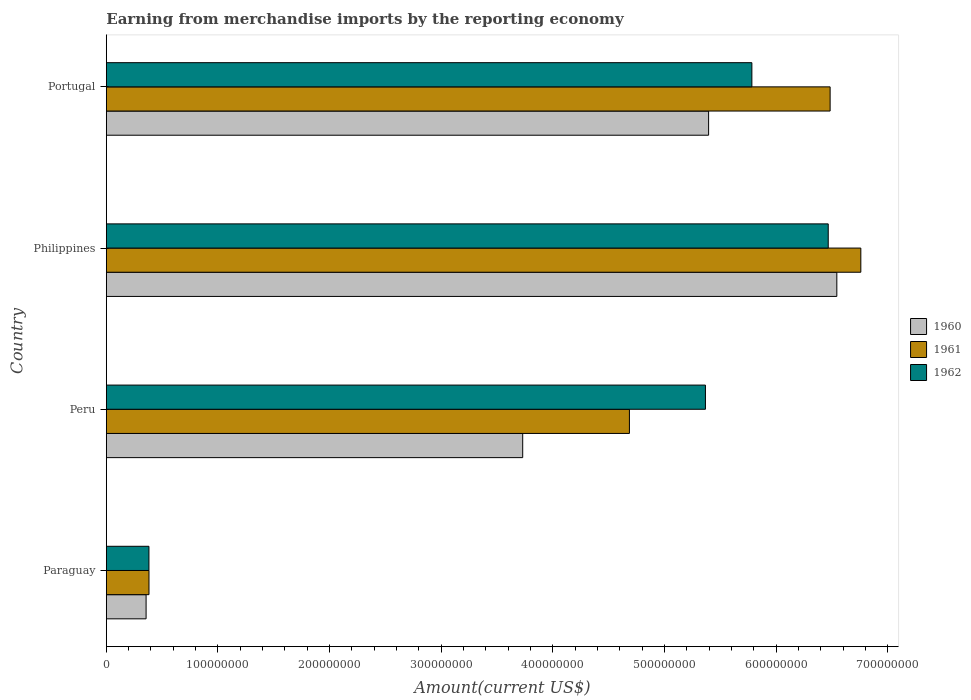How many different coloured bars are there?
Ensure brevity in your answer.  3. Are the number of bars on each tick of the Y-axis equal?
Offer a very short reply. Yes. How many bars are there on the 4th tick from the top?
Keep it short and to the point. 3. In how many cases, is the number of bars for a given country not equal to the number of legend labels?
Provide a short and direct response. 0. What is the amount earned from merchandise imports in 1962 in Peru?
Ensure brevity in your answer.  5.37e+08. Across all countries, what is the maximum amount earned from merchandise imports in 1962?
Provide a short and direct response. 6.47e+08. Across all countries, what is the minimum amount earned from merchandise imports in 1961?
Provide a succinct answer. 3.82e+07. In which country was the amount earned from merchandise imports in 1962 minimum?
Offer a terse response. Paraguay. What is the total amount earned from merchandise imports in 1961 in the graph?
Provide a succinct answer. 1.83e+09. What is the difference between the amount earned from merchandise imports in 1961 in Peru and that in Portugal?
Make the answer very short. -1.80e+08. What is the difference between the amount earned from merchandise imports in 1960 in Peru and the amount earned from merchandise imports in 1962 in Portugal?
Your response must be concise. -2.05e+08. What is the average amount earned from merchandise imports in 1961 per country?
Provide a succinct answer. 4.58e+08. What is the difference between the amount earned from merchandise imports in 1962 and amount earned from merchandise imports in 1960 in Peru?
Offer a very short reply. 1.64e+08. What is the ratio of the amount earned from merchandise imports in 1961 in Peru to that in Philippines?
Provide a succinct answer. 0.69. Is the difference between the amount earned from merchandise imports in 1962 in Peru and Portugal greater than the difference between the amount earned from merchandise imports in 1960 in Peru and Portugal?
Provide a short and direct response. Yes. What is the difference between the highest and the second highest amount earned from merchandise imports in 1961?
Give a very brief answer. 2.75e+07. What is the difference between the highest and the lowest amount earned from merchandise imports in 1961?
Keep it short and to the point. 6.38e+08. In how many countries, is the amount earned from merchandise imports in 1961 greater than the average amount earned from merchandise imports in 1961 taken over all countries?
Keep it short and to the point. 3. What does the 3rd bar from the top in Philippines represents?
Make the answer very short. 1960. Is it the case that in every country, the sum of the amount earned from merchandise imports in 1962 and amount earned from merchandise imports in 1961 is greater than the amount earned from merchandise imports in 1960?
Your answer should be compact. Yes. How many bars are there?
Provide a short and direct response. 12. Are all the bars in the graph horizontal?
Ensure brevity in your answer.  Yes. How many countries are there in the graph?
Keep it short and to the point. 4. What is the difference between two consecutive major ticks on the X-axis?
Give a very brief answer. 1.00e+08. Are the values on the major ticks of X-axis written in scientific E-notation?
Give a very brief answer. No. Does the graph contain grids?
Your answer should be very brief. No. What is the title of the graph?
Offer a terse response. Earning from merchandise imports by the reporting economy. What is the label or title of the X-axis?
Give a very brief answer. Amount(current US$). What is the label or title of the Y-axis?
Ensure brevity in your answer.  Country. What is the Amount(current US$) of 1960 in Paraguay?
Your response must be concise. 3.56e+07. What is the Amount(current US$) in 1961 in Paraguay?
Your response must be concise. 3.82e+07. What is the Amount(current US$) in 1962 in Paraguay?
Offer a very short reply. 3.82e+07. What is the Amount(current US$) of 1960 in Peru?
Provide a short and direct response. 3.73e+08. What is the Amount(current US$) of 1961 in Peru?
Your answer should be compact. 4.69e+08. What is the Amount(current US$) in 1962 in Peru?
Keep it short and to the point. 5.37e+08. What is the Amount(current US$) of 1960 in Philippines?
Your response must be concise. 6.54e+08. What is the Amount(current US$) of 1961 in Philippines?
Provide a succinct answer. 6.76e+08. What is the Amount(current US$) of 1962 in Philippines?
Provide a short and direct response. 6.47e+08. What is the Amount(current US$) of 1960 in Portugal?
Offer a terse response. 5.40e+08. What is the Amount(current US$) of 1961 in Portugal?
Your answer should be very brief. 6.48e+08. What is the Amount(current US$) in 1962 in Portugal?
Offer a terse response. 5.78e+08. Across all countries, what is the maximum Amount(current US$) in 1960?
Offer a very short reply. 6.54e+08. Across all countries, what is the maximum Amount(current US$) of 1961?
Ensure brevity in your answer.  6.76e+08. Across all countries, what is the maximum Amount(current US$) in 1962?
Provide a short and direct response. 6.47e+08. Across all countries, what is the minimum Amount(current US$) of 1960?
Give a very brief answer. 3.56e+07. Across all countries, what is the minimum Amount(current US$) of 1961?
Make the answer very short. 3.82e+07. Across all countries, what is the minimum Amount(current US$) in 1962?
Your response must be concise. 3.82e+07. What is the total Amount(current US$) of 1960 in the graph?
Keep it short and to the point. 1.60e+09. What is the total Amount(current US$) in 1961 in the graph?
Offer a terse response. 1.83e+09. What is the total Amount(current US$) in 1962 in the graph?
Your response must be concise. 1.80e+09. What is the difference between the Amount(current US$) in 1960 in Paraguay and that in Peru?
Provide a short and direct response. -3.37e+08. What is the difference between the Amount(current US$) of 1961 in Paraguay and that in Peru?
Your response must be concise. -4.30e+08. What is the difference between the Amount(current US$) in 1962 in Paraguay and that in Peru?
Your answer should be very brief. -4.99e+08. What is the difference between the Amount(current US$) of 1960 in Paraguay and that in Philippines?
Give a very brief answer. -6.19e+08. What is the difference between the Amount(current US$) in 1961 in Paraguay and that in Philippines?
Provide a short and direct response. -6.38e+08. What is the difference between the Amount(current US$) of 1962 in Paraguay and that in Philippines?
Offer a terse response. -6.09e+08. What is the difference between the Amount(current US$) of 1960 in Paraguay and that in Portugal?
Keep it short and to the point. -5.04e+08. What is the difference between the Amount(current US$) of 1961 in Paraguay and that in Portugal?
Offer a very short reply. -6.10e+08. What is the difference between the Amount(current US$) in 1962 in Paraguay and that in Portugal?
Your answer should be compact. -5.40e+08. What is the difference between the Amount(current US$) of 1960 in Peru and that in Philippines?
Offer a terse response. -2.81e+08. What is the difference between the Amount(current US$) of 1961 in Peru and that in Philippines?
Offer a very short reply. -2.07e+08. What is the difference between the Amount(current US$) in 1962 in Peru and that in Philippines?
Your answer should be compact. -1.10e+08. What is the difference between the Amount(current US$) in 1960 in Peru and that in Portugal?
Keep it short and to the point. -1.67e+08. What is the difference between the Amount(current US$) in 1961 in Peru and that in Portugal?
Provide a short and direct response. -1.80e+08. What is the difference between the Amount(current US$) in 1962 in Peru and that in Portugal?
Your answer should be very brief. -4.16e+07. What is the difference between the Amount(current US$) in 1960 in Philippines and that in Portugal?
Give a very brief answer. 1.15e+08. What is the difference between the Amount(current US$) of 1961 in Philippines and that in Portugal?
Keep it short and to the point. 2.75e+07. What is the difference between the Amount(current US$) of 1962 in Philippines and that in Portugal?
Keep it short and to the point. 6.84e+07. What is the difference between the Amount(current US$) of 1960 in Paraguay and the Amount(current US$) of 1961 in Peru?
Provide a short and direct response. -4.33e+08. What is the difference between the Amount(current US$) in 1960 in Paraguay and the Amount(current US$) in 1962 in Peru?
Offer a very short reply. -5.01e+08. What is the difference between the Amount(current US$) in 1961 in Paraguay and the Amount(current US$) in 1962 in Peru?
Provide a succinct answer. -4.98e+08. What is the difference between the Amount(current US$) in 1960 in Paraguay and the Amount(current US$) in 1961 in Philippines?
Make the answer very short. -6.40e+08. What is the difference between the Amount(current US$) of 1960 in Paraguay and the Amount(current US$) of 1962 in Philippines?
Keep it short and to the point. -6.11e+08. What is the difference between the Amount(current US$) in 1961 in Paraguay and the Amount(current US$) in 1962 in Philippines?
Your answer should be compact. -6.08e+08. What is the difference between the Amount(current US$) of 1960 in Paraguay and the Amount(current US$) of 1961 in Portugal?
Offer a terse response. -6.13e+08. What is the difference between the Amount(current US$) in 1960 in Paraguay and the Amount(current US$) in 1962 in Portugal?
Your answer should be compact. -5.43e+08. What is the difference between the Amount(current US$) of 1961 in Paraguay and the Amount(current US$) of 1962 in Portugal?
Your response must be concise. -5.40e+08. What is the difference between the Amount(current US$) in 1960 in Peru and the Amount(current US$) in 1961 in Philippines?
Keep it short and to the point. -3.03e+08. What is the difference between the Amount(current US$) in 1960 in Peru and the Amount(current US$) in 1962 in Philippines?
Make the answer very short. -2.74e+08. What is the difference between the Amount(current US$) in 1961 in Peru and the Amount(current US$) in 1962 in Philippines?
Make the answer very short. -1.78e+08. What is the difference between the Amount(current US$) in 1960 in Peru and the Amount(current US$) in 1961 in Portugal?
Offer a very short reply. -2.75e+08. What is the difference between the Amount(current US$) of 1960 in Peru and the Amount(current US$) of 1962 in Portugal?
Ensure brevity in your answer.  -2.05e+08. What is the difference between the Amount(current US$) in 1961 in Peru and the Amount(current US$) in 1962 in Portugal?
Keep it short and to the point. -1.10e+08. What is the difference between the Amount(current US$) of 1960 in Philippines and the Amount(current US$) of 1961 in Portugal?
Provide a succinct answer. 6.01e+06. What is the difference between the Amount(current US$) in 1960 in Philippines and the Amount(current US$) in 1962 in Portugal?
Offer a very short reply. 7.61e+07. What is the difference between the Amount(current US$) in 1961 in Philippines and the Amount(current US$) in 1962 in Portugal?
Make the answer very short. 9.76e+07. What is the average Amount(current US$) of 1960 per country?
Make the answer very short. 4.01e+08. What is the average Amount(current US$) of 1961 per country?
Your answer should be very brief. 4.58e+08. What is the average Amount(current US$) of 1962 per country?
Offer a terse response. 4.50e+08. What is the difference between the Amount(current US$) in 1960 and Amount(current US$) in 1961 in Paraguay?
Make the answer very short. -2.59e+06. What is the difference between the Amount(current US$) of 1960 and Amount(current US$) of 1962 in Paraguay?
Make the answer very short. -2.55e+06. What is the difference between the Amount(current US$) of 1961 and Amount(current US$) of 1962 in Paraguay?
Offer a terse response. 3.80e+04. What is the difference between the Amount(current US$) of 1960 and Amount(current US$) of 1961 in Peru?
Provide a short and direct response. -9.56e+07. What is the difference between the Amount(current US$) in 1960 and Amount(current US$) in 1962 in Peru?
Make the answer very short. -1.64e+08. What is the difference between the Amount(current US$) of 1961 and Amount(current US$) of 1962 in Peru?
Your response must be concise. -6.81e+07. What is the difference between the Amount(current US$) of 1960 and Amount(current US$) of 1961 in Philippines?
Your answer should be very brief. -2.15e+07. What is the difference between the Amount(current US$) in 1960 and Amount(current US$) in 1962 in Philippines?
Provide a succinct answer. 7.70e+06. What is the difference between the Amount(current US$) of 1961 and Amount(current US$) of 1962 in Philippines?
Make the answer very short. 2.92e+07. What is the difference between the Amount(current US$) in 1960 and Amount(current US$) in 1961 in Portugal?
Give a very brief answer. -1.09e+08. What is the difference between the Amount(current US$) in 1960 and Amount(current US$) in 1962 in Portugal?
Your answer should be very brief. -3.88e+07. What is the difference between the Amount(current US$) of 1961 and Amount(current US$) of 1962 in Portugal?
Your answer should be compact. 7.01e+07. What is the ratio of the Amount(current US$) of 1960 in Paraguay to that in Peru?
Provide a succinct answer. 0.1. What is the ratio of the Amount(current US$) of 1961 in Paraguay to that in Peru?
Your answer should be very brief. 0.08. What is the ratio of the Amount(current US$) of 1962 in Paraguay to that in Peru?
Ensure brevity in your answer.  0.07. What is the ratio of the Amount(current US$) of 1960 in Paraguay to that in Philippines?
Keep it short and to the point. 0.05. What is the ratio of the Amount(current US$) in 1961 in Paraguay to that in Philippines?
Provide a succinct answer. 0.06. What is the ratio of the Amount(current US$) of 1962 in Paraguay to that in Philippines?
Your response must be concise. 0.06. What is the ratio of the Amount(current US$) in 1960 in Paraguay to that in Portugal?
Provide a succinct answer. 0.07. What is the ratio of the Amount(current US$) in 1961 in Paraguay to that in Portugal?
Keep it short and to the point. 0.06. What is the ratio of the Amount(current US$) of 1962 in Paraguay to that in Portugal?
Provide a short and direct response. 0.07. What is the ratio of the Amount(current US$) of 1960 in Peru to that in Philippines?
Provide a short and direct response. 0.57. What is the ratio of the Amount(current US$) in 1961 in Peru to that in Philippines?
Give a very brief answer. 0.69. What is the ratio of the Amount(current US$) of 1962 in Peru to that in Philippines?
Your answer should be compact. 0.83. What is the ratio of the Amount(current US$) in 1960 in Peru to that in Portugal?
Offer a very short reply. 0.69. What is the ratio of the Amount(current US$) of 1961 in Peru to that in Portugal?
Your answer should be compact. 0.72. What is the ratio of the Amount(current US$) of 1962 in Peru to that in Portugal?
Your answer should be compact. 0.93. What is the ratio of the Amount(current US$) in 1960 in Philippines to that in Portugal?
Offer a terse response. 1.21. What is the ratio of the Amount(current US$) of 1961 in Philippines to that in Portugal?
Keep it short and to the point. 1.04. What is the ratio of the Amount(current US$) in 1962 in Philippines to that in Portugal?
Provide a succinct answer. 1.12. What is the difference between the highest and the second highest Amount(current US$) in 1960?
Make the answer very short. 1.15e+08. What is the difference between the highest and the second highest Amount(current US$) in 1961?
Make the answer very short. 2.75e+07. What is the difference between the highest and the second highest Amount(current US$) in 1962?
Your answer should be compact. 6.84e+07. What is the difference between the highest and the lowest Amount(current US$) in 1960?
Keep it short and to the point. 6.19e+08. What is the difference between the highest and the lowest Amount(current US$) of 1961?
Make the answer very short. 6.38e+08. What is the difference between the highest and the lowest Amount(current US$) in 1962?
Make the answer very short. 6.09e+08. 